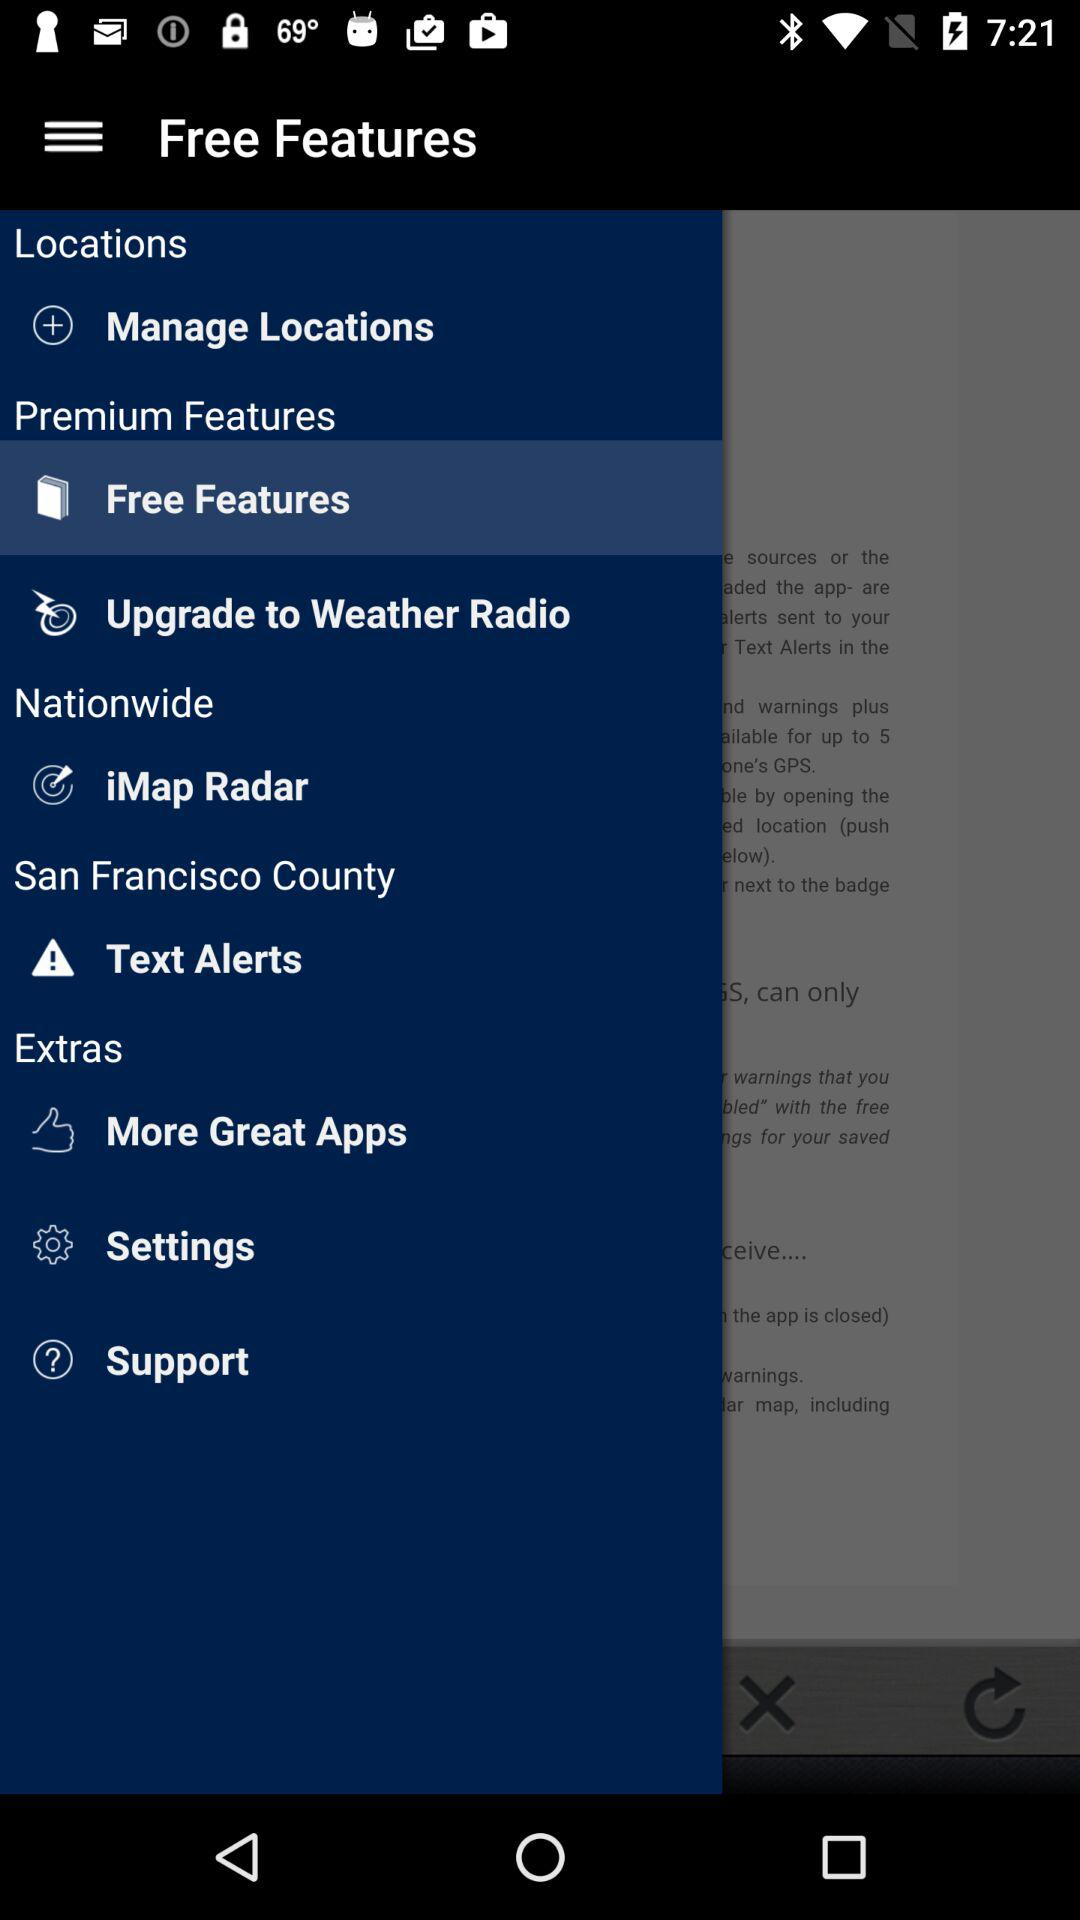What is the selected item in "Premium Features"? The selected item in "Premium Features" is "Free Features". 